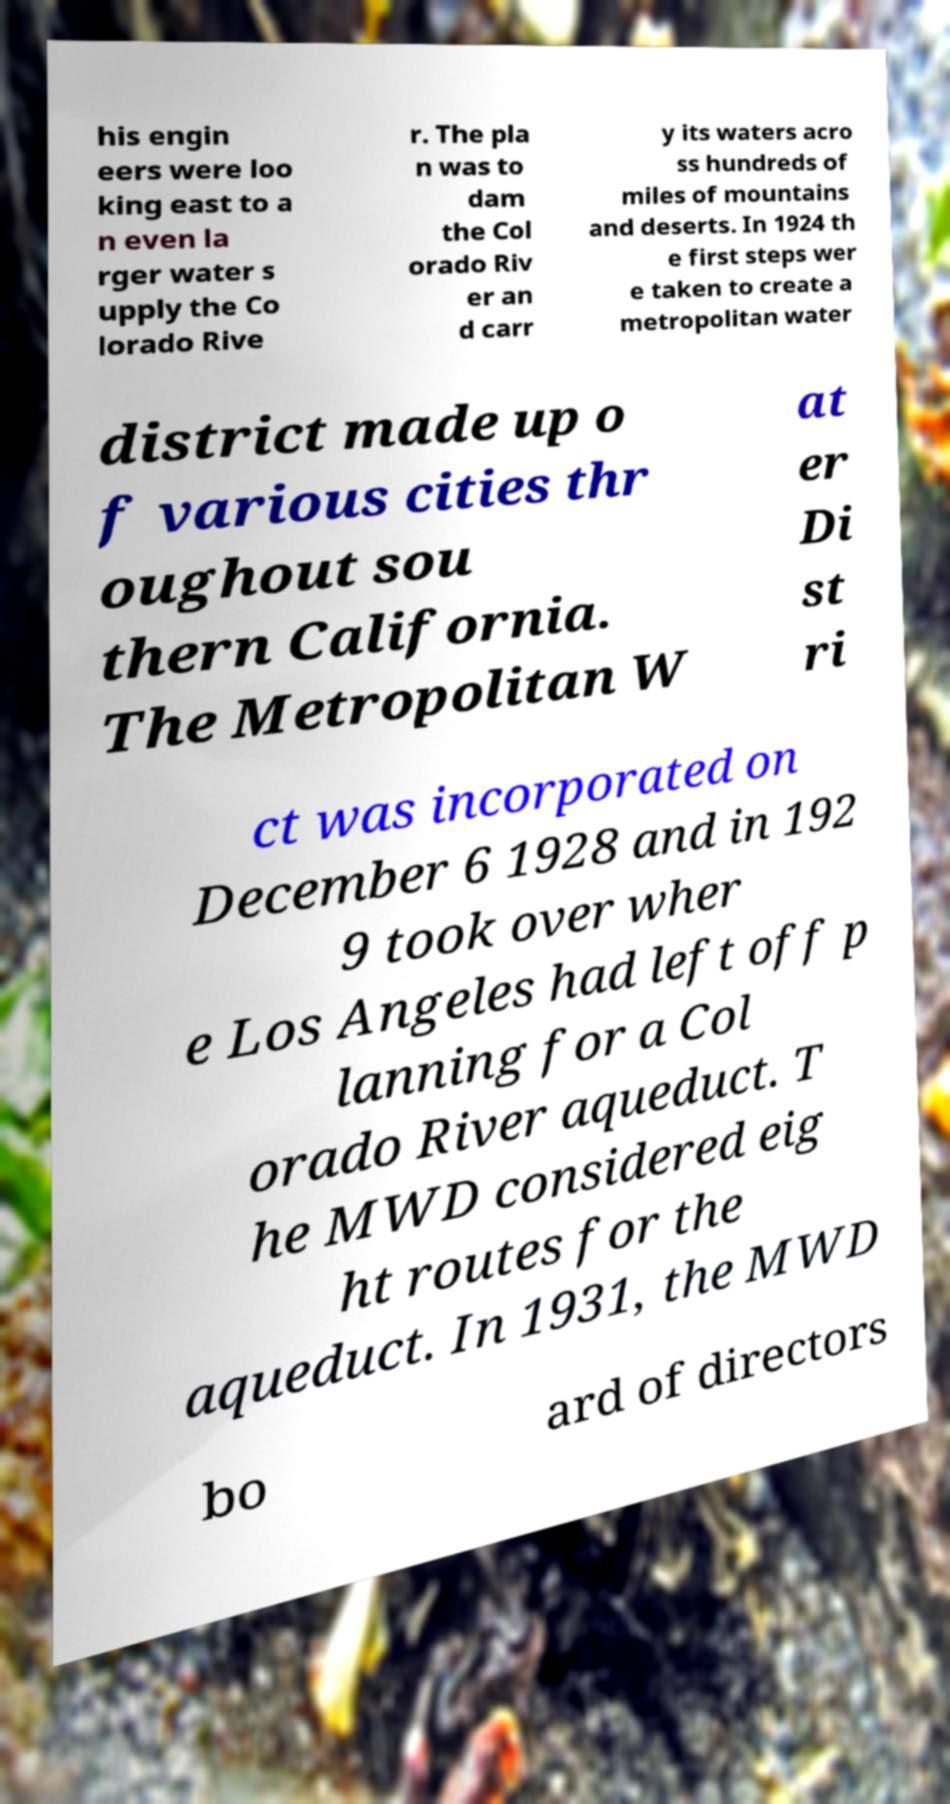Can you read and provide the text displayed in the image?This photo seems to have some interesting text. Can you extract and type it out for me? his engin eers were loo king east to a n even la rger water s upply the Co lorado Rive r. The pla n was to dam the Col orado Riv er an d carr y its waters acro ss hundreds of miles of mountains and deserts. In 1924 th e first steps wer e taken to create a metropolitan water district made up o f various cities thr oughout sou thern California. The Metropolitan W at er Di st ri ct was incorporated on December 6 1928 and in 192 9 took over wher e Los Angeles had left off p lanning for a Col orado River aqueduct. T he MWD considered eig ht routes for the aqueduct. In 1931, the MWD bo ard of directors 